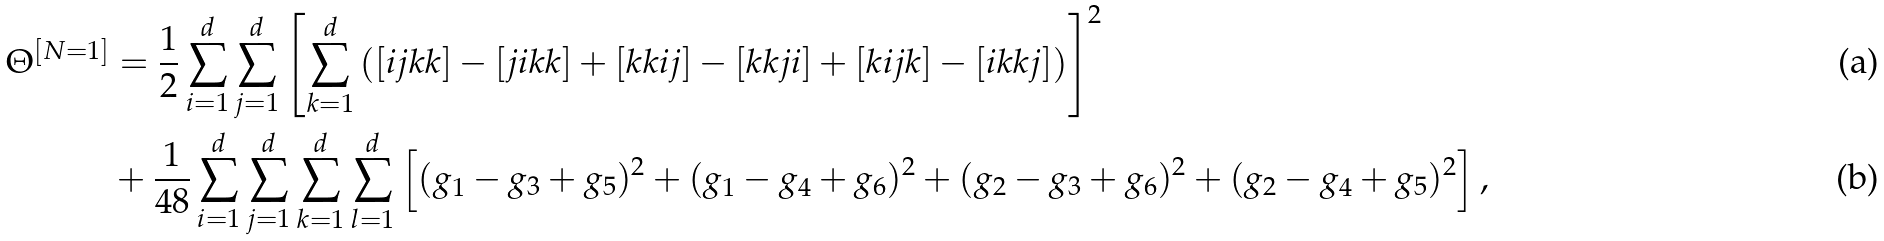<formula> <loc_0><loc_0><loc_500><loc_500>\Theta ^ { [ N = 1 ] } & = \frac { 1 } { 2 } \sum _ { i = 1 } ^ { d } \sum _ { j = 1 } ^ { d } \left [ \sum _ { k = 1 } ^ { d } \left ( [ i j k k ] - [ j i k k ] + [ k k i j ] - [ k k j i ] + [ k i j k ] - [ i k k j ] \right ) \right ] ^ { 2 } \\ & + \frac { 1 } { 4 8 } \sum _ { i = 1 } ^ { d } \sum _ { j = 1 } ^ { d } \sum _ { k = 1 } ^ { d } \sum _ { l = 1 } ^ { d } \left [ ( g _ { 1 } - g _ { 3 } + g _ { 5 } ) ^ { 2 } + ( g _ { 1 } - g _ { 4 } + g _ { 6 } ) ^ { 2 } + ( g _ { 2 } - g _ { 3 } + g _ { 6 } ) ^ { 2 } + ( g _ { 2 } - g _ { 4 } + g _ { 5 } ) ^ { 2 } \right ] ,</formula> 